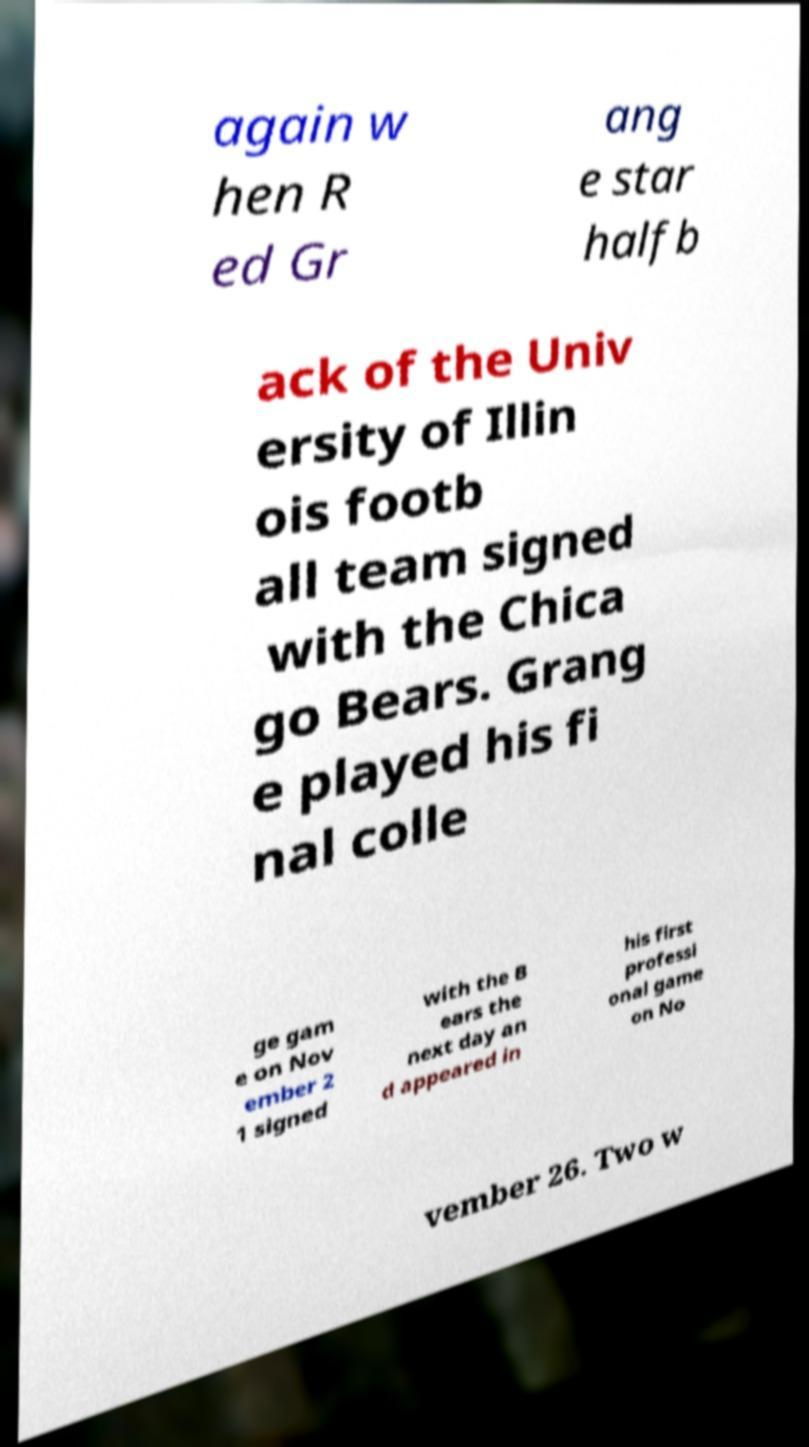What messages or text are displayed in this image? I need them in a readable, typed format. again w hen R ed Gr ang e star halfb ack of the Univ ersity of Illin ois footb all team signed with the Chica go Bears. Grang e played his fi nal colle ge gam e on Nov ember 2 1 signed with the B ears the next day an d appeared in his first professi onal game on No vember 26. Two w 